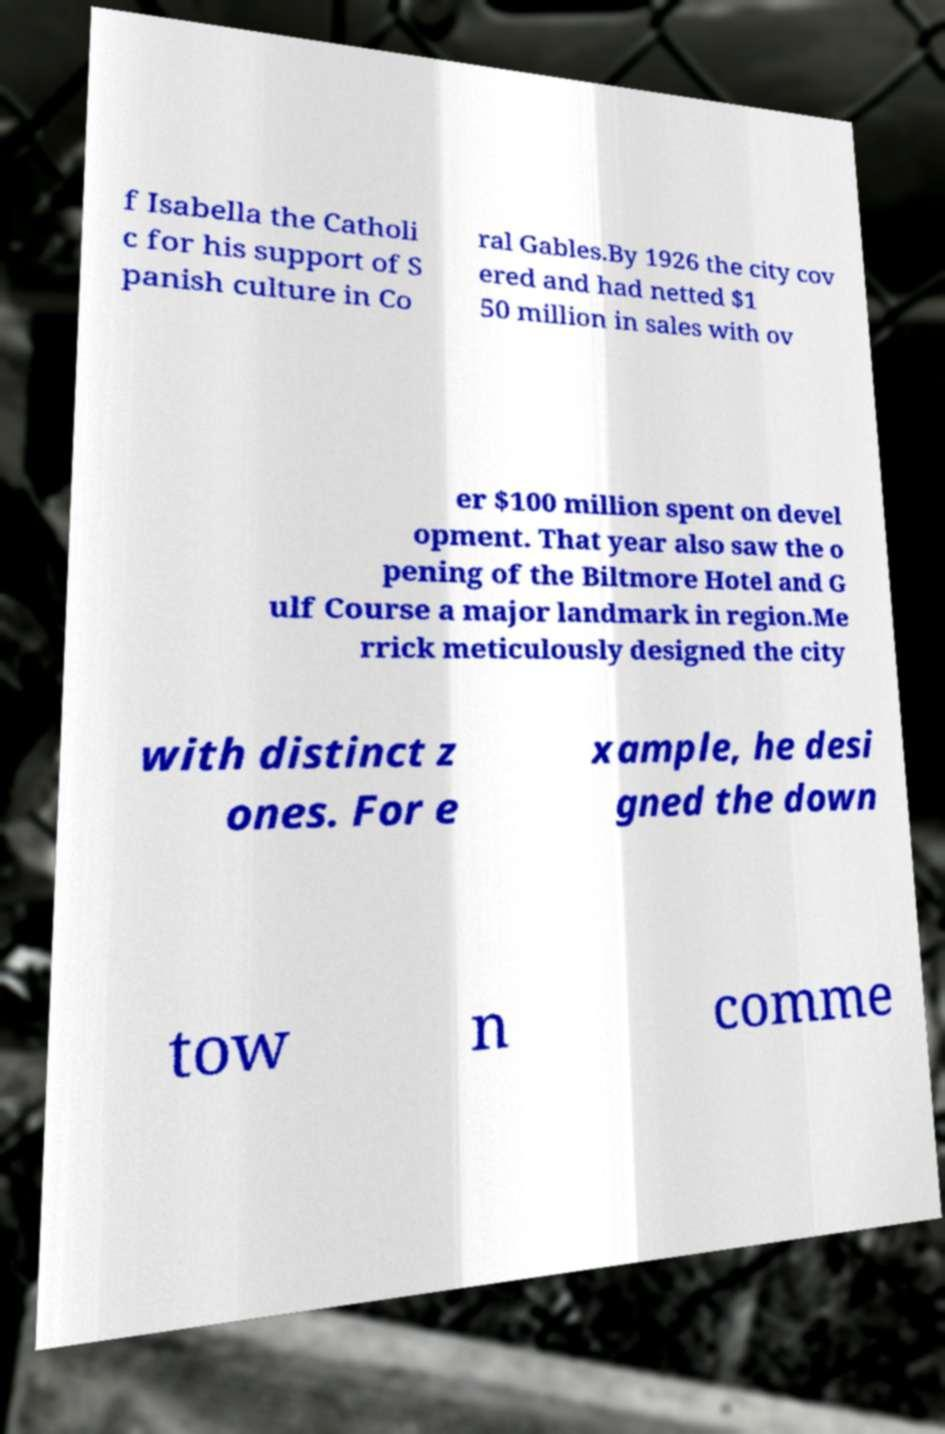Please identify and transcribe the text found in this image. f Isabella the Catholi c for his support of S panish culture in Co ral Gables.By 1926 the city cov ered and had netted $1 50 million in sales with ov er $100 million spent on devel opment. That year also saw the o pening of the Biltmore Hotel and G ulf Course a major landmark in region.Me rrick meticulously designed the city with distinct z ones. For e xample, he desi gned the down tow n comme 